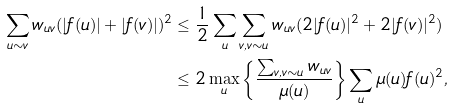Convert formula to latex. <formula><loc_0><loc_0><loc_500><loc_500>\sum _ { u \sim v } w _ { u v } ( | f ( u ) | + | f ( v ) | ) ^ { 2 } & \leq \frac { 1 } { 2 } \sum _ { u } \sum _ { v , v \sim u } w _ { u v } ( 2 | f ( u ) | ^ { 2 } + 2 | f ( v ) | ^ { 2 } ) \\ & \leq 2 \max _ { u } \left \{ \frac { \sum _ { v , v \sim u } w _ { u v } } { \mu ( u ) } \right \} \sum _ { u } \mu ( u ) f ( u ) ^ { 2 } ,</formula> 